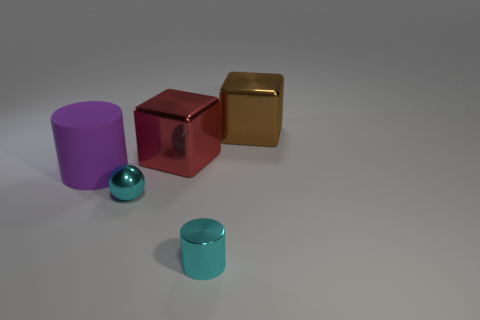Add 1 small green rubber blocks. How many objects exist? 6 Subtract all cylinders. How many objects are left? 3 Add 4 big red metallic things. How many big red metallic things are left? 5 Add 3 brown objects. How many brown objects exist? 4 Subtract 0 green balls. How many objects are left? 5 Subtract all tiny purple things. Subtract all cyan shiny cylinders. How many objects are left? 4 